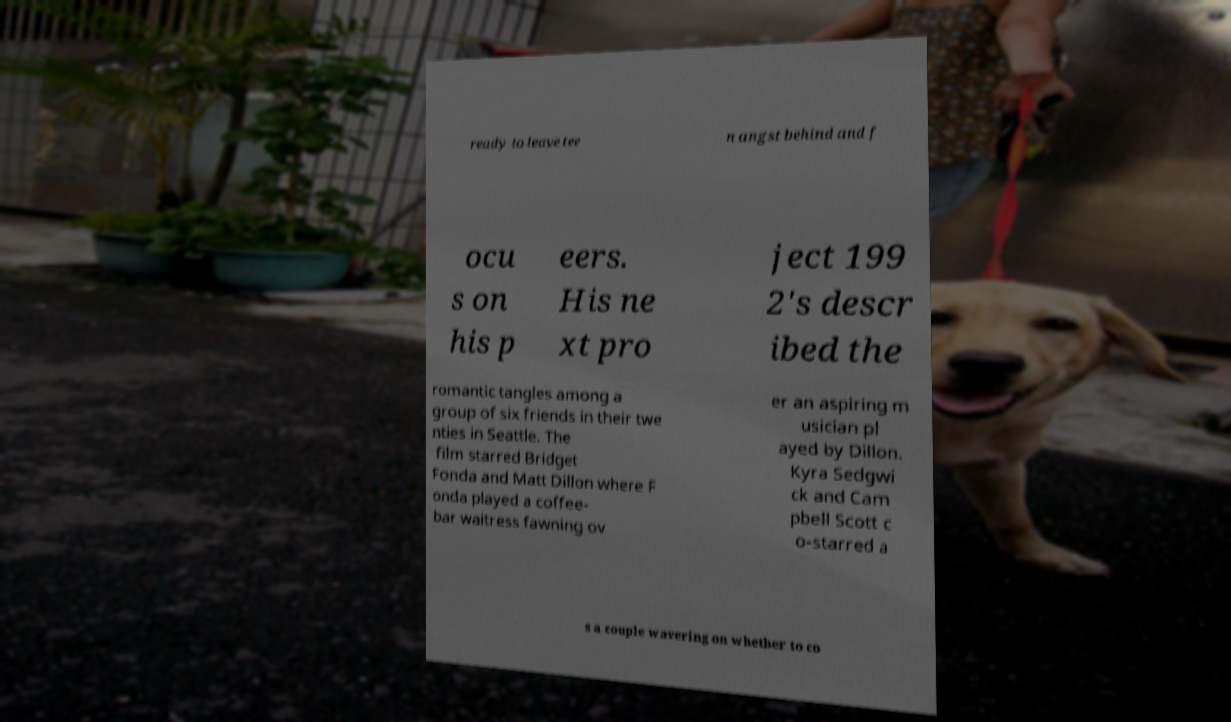Could you assist in decoding the text presented in this image and type it out clearly? ready to leave tee n angst behind and f ocu s on his p eers. His ne xt pro ject 199 2's descr ibed the romantic tangles among a group of six friends in their twe nties in Seattle. The film starred Bridget Fonda and Matt Dillon where F onda played a coffee- bar waitress fawning ov er an aspiring m usician pl ayed by Dillon. Kyra Sedgwi ck and Cam pbell Scott c o-starred a s a couple wavering on whether to co 